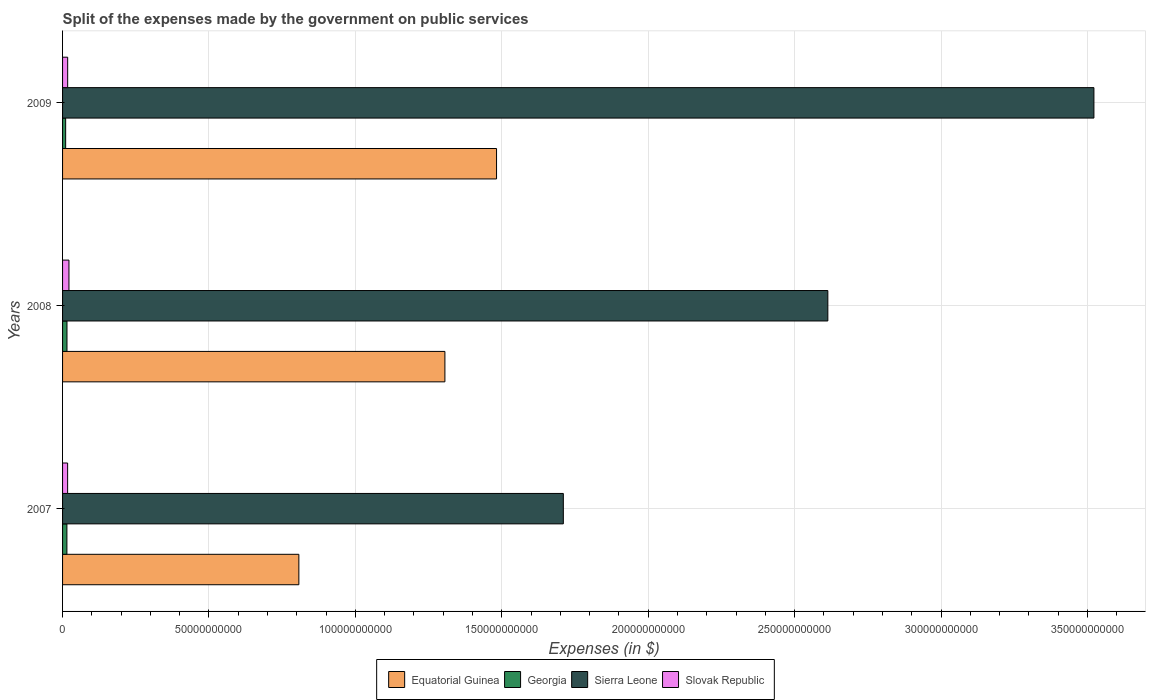How many different coloured bars are there?
Give a very brief answer. 4. Are the number of bars per tick equal to the number of legend labels?
Give a very brief answer. Yes. How many bars are there on the 3rd tick from the bottom?
Your answer should be very brief. 4. What is the expenses made by the government on public services in Equatorial Guinea in 2007?
Your response must be concise. 8.07e+1. Across all years, what is the maximum expenses made by the government on public services in Slovak Republic?
Provide a short and direct response. 2.18e+09. Across all years, what is the minimum expenses made by the government on public services in Slovak Republic?
Keep it short and to the point. 1.73e+09. What is the total expenses made by the government on public services in Equatorial Guinea in the graph?
Give a very brief answer. 3.59e+11. What is the difference between the expenses made by the government on public services in Sierra Leone in 2008 and that in 2009?
Provide a succinct answer. -9.09e+1. What is the difference between the expenses made by the government on public services in Equatorial Guinea in 2008 and the expenses made by the government on public services in Georgia in 2007?
Provide a succinct answer. 1.29e+11. What is the average expenses made by the government on public services in Georgia per year?
Provide a short and direct response. 1.35e+09. In the year 2007, what is the difference between the expenses made by the government on public services in Georgia and expenses made by the government on public services in Slovak Republic?
Keep it short and to the point. -2.45e+08. In how many years, is the expenses made by the government on public services in Sierra Leone greater than 90000000000 $?
Offer a terse response. 3. What is the ratio of the expenses made by the government on public services in Sierra Leone in 2007 to that in 2008?
Offer a very short reply. 0.65. Is the difference between the expenses made by the government on public services in Georgia in 2007 and 2008 greater than the difference between the expenses made by the government on public services in Slovak Republic in 2007 and 2008?
Give a very brief answer. Yes. What is the difference between the highest and the second highest expenses made by the government on public services in Equatorial Guinea?
Provide a short and direct response. 1.76e+1. What is the difference between the highest and the lowest expenses made by the government on public services in Georgia?
Your response must be concise. 4.54e+08. Is the sum of the expenses made by the government on public services in Georgia in 2007 and 2009 greater than the maximum expenses made by the government on public services in Sierra Leone across all years?
Ensure brevity in your answer.  No. Is it the case that in every year, the sum of the expenses made by the government on public services in Georgia and expenses made by the government on public services in Equatorial Guinea is greater than the sum of expenses made by the government on public services in Sierra Leone and expenses made by the government on public services in Slovak Republic?
Ensure brevity in your answer.  Yes. What does the 1st bar from the top in 2007 represents?
Give a very brief answer. Slovak Republic. What does the 3rd bar from the bottom in 2008 represents?
Your answer should be very brief. Sierra Leone. How many bars are there?
Your answer should be very brief. 12. What is the difference between two consecutive major ticks on the X-axis?
Offer a terse response. 5.00e+1. Are the values on the major ticks of X-axis written in scientific E-notation?
Offer a terse response. No. Does the graph contain grids?
Your answer should be very brief. Yes. Where does the legend appear in the graph?
Ensure brevity in your answer.  Bottom center. How many legend labels are there?
Make the answer very short. 4. What is the title of the graph?
Ensure brevity in your answer.  Split of the expenses made by the government on public services. Does "Vanuatu" appear as one of the legend labels in the graph?
Offer a terse response. No. What is the label or title of the X-axis?
Provide a succinct answer. Expenses (in $). What is the Expenses (in $) in Equatorial Guinea in 2007?
Offer a very short reply. 8.07e+1. What is the Expenses (in $) of Georgia in 2007?
Provide a short and direct response. 1.48e+09. What is the Expenses (in $) of Sierra Leone in 2007?
Keep it short and to the point. 1.71e+11. What is the Expenses (in $) of Slovak Republic in 2007?
Offer a terse response. 1.73e+09. What is the Expenses (in $) of Equatorial Guinea in 2008?
Ensure brevity in your answer.  1.31e+11. What is the Expenses (in $) of Georgia in 2008?
Your answer should be compact. 1.51e+09. What is the Expenses (in $) in Sierra Leone in 2008?
Make the answer very short. 2.61e+11. What is the Expenses (in $) of Slovak Republic in 2008?
Make the answer very short. 2.18e+09. What is the Expenses (in $) of Equatorial Guinea in 2009?
Your response must be concise. 1.48e+11. What is the Expenses (in $) of Georgia in 2009?
Ensure brevity in your answer.  1.06e+09. What is the Expenses (in $) in Sierra Leone in 2009?
Your answer should be very brief. 3.52e+11. What is the Expenses (in $) in Slovak Republic in 2009?
Offer a very short reply. 1.74e+09. Across all years, what is the maximum Expenses (in $) of Equatorial Guinea?
Ensure brevity in your answer.  1.48e+11. Across all years, what is the maximum Expenses (in $) of Georgia?
Offer a terse response. 1.51e+09. Across all years, what is the maximum Expenses (in $) of Sierra Leone?
Your response must be concise. 3.52e+11. Across all years, what is the maximum Expenses (in $) of Slovak Republic?
Provide a succinct answer. 2.18e+09. Across all years, what is the minimum Expenses (in $) in Equatorial Guinea?
Provide a succinct answer. 8.07e+1. Across all years, what is the minimum Expenses (in $) in Georgia?
Offer a very short reply. 1.06e+09. Across all years, what is the minimum Expenses (in $) in Sierra Leone?
Make the answer very short. 1.71e+11. Across all years, what is the minimum Expenses (in $) of Slovak Republic?
Your response must be concise. 1.73e+09. What is the total Expenses (in $) in Equatorial Guinea in the graph?
Keep it short and to the point. 3.59e+11. What is the total Expenses (in $) in Georgia in the graph?
Offer a terse response. 4.05e+09. What is the total Expenses (in $) of Sierra Leone in the graph?
Ensure brevity in your answer.  7.85e+11. What is the total Expenses (in $) of Slovak Republic in the graph?
Your response must be concise. 5.65e+09. What is the difference between the Expenses (in $) in Equatorial Guinea in 2007 and that in 2008?
Provide a short and direct response. -4.99e+1. What is the difference between the Expenses (in $) of Georgia in 2007 and that in 2008?
Offer a very short reply. -2.49e+07. What is the difference between the Expenses (in $) in Sierra Leone in 2007 and that in 2008?
Your answer should be very brief. -9.03e+1. What is the difference between the Expenses (in $) in Slovak Republic in 2007 and that in 2008?
Offer a terse response. -4.53e+08. What is the difference between the Expenses (in $) in Equatorial Guinea in 2007 and that in 2009?
Your answer should be compact. -6.75e+1. What is the difference between the Expenses (in $) of Georgia in 2007 and that in 2009?
Ensure brevity in your answer.  4.29e+08. What is the difference between the Expenses (in $) in Sierra Leone in 2007 and that in 2009?
Your response must be concise. -1.81e+11. What is the difference between the Expenses (in $) in Slovak Republic in 2007 and that in 2009?
Provide a succinct answer. -1.42e+07. What is the difference between the Expenses (in $) in Equatorial Guinea in 2008 and that in 2009?
Provide a short and direct response. -1.76e+1. What is the difference between the Expenses (in $) in Georgia in 2008 and that in 2009?
Give a very brief answer. 4.54e+08. What is the difference between the Expenses (in $) of Sierra Leone in 2008 and that in 2009?
Offer a terse response. -9.09e+1. What is the difference between the Expenses (in $) of Slovak Republic in 2008 and that in 2009?
Your answer should be compact. 4.39e+08. What is the difference between the Expenses (in $) of Equatorial Guinea in 2007 and the Expenses (in $) of Georgia in 2008?
Ensure brevity in your answer.  7.92e+1. What is the difference between the Expenses (in $) of Equatorial Guinea in 2007 and the Expenses (in $) of Sierra Leone in 2008?
Provide a succinct answer. -1.81e+11. What is the difference between the Expenses (in $) in Equatorial Guinea in 2007 and the Expenses (in $) in Slovak Republic in 2008?
Give a very brief answer. 7.85e+1. What is the difference between the Expenses (in $) in Georgia in 2007 and the Expenses (in $) in Sierra Leone in 2008?
Provide a short and direct response. -2.60e+11. What is the difference between the Expenses (in $) of Georgia in 2007 and the Expenses (in $) of Slovak Republic in 2008?
Provide a succinct answer. -6.98e+08. What is the difference between the Expenses (in $) of Sierra Leone in 2007 and the Expenses (in $) of Slovak Republic in 2008?
Ensure brevity in your answer.  1.69e+11. What is the difference between the Expenses (in $) of Equatorial Guinea in 2007 and the Expenses (in $) of Georgia in 2009?
Your answer should be very brief. 7.96e+1. What is the difference between the Expenses (in $) of Equatorial Guinea in 2007 and the Expenses (in $) of Sierra Leone in 2009?
Make the answer very short. -2.71e+11. What is the difference between the Expenses (in $) in Equatorial Guinea in 2007 and the Expenses (in $) in Slovak Republic in 2009?
Offer a terse response. 7.89e+1. What is the difference between the Expenses (in $) in Georgia in 2007 and the Expenses (in $) in Sierra Leone in 2009?
Offer a very short reply. -3.51e+11. What is the difference between the Expenses (in $) of Georgia in 2007 and the Expenses (in $) of Slovak Republic in 2009?
Provide a short and direct response. -2.60e+08. What is the difference between the Expenses (in $) of Sierra Leone in 2007 and the Expenses (in $) of Slovak Republic in 2009?
Your response must be concise. 1.69e+11. What is the difference between the Expenses (in $) in Equatorial Guinea in 2008 and the Expenses (in $) in Georgia in 2009?
Keep it short and to the point. 1.30e+11. What is the difference between the Expenses (in $) in Equatorial Guinea in 2008 and the Expenses (in $) in Sierra Leone in 2009?
Provide a short and direct response. -2.22e+11. What is the difference between the Expenses (in $) of Equatorial Guinea in 2008 and the Expenses (in $) of Slovak Republic in 2009?
Offer a terse response. 1.29e+11. What is the difference between the Expenses (in $) in Georgia in 2008 and the Expenses (in $) in Sierra Leone in 2009?
Your response must be concise. -3.51e+11. What is the difference between the Expenses (in $) in Georgia in 2008 and the Expenses (in $) in Slovak Republic in 2009?
Give a very brief answer. -2.35e+08. What is the difference between the Expenses (in $) of Sierra Leone in 2008 and the Expenses (in $) of Slovak Republic in 2009?
Make the answer very short. 2.60e+11. What is the average Expenses (in $) in Equatorial Guinea per year?
Make the answer very short. 1.20e+11. What is the average Expenses (in $) in Georgia per year?
Offer a terse response. 1.35e+09. What is the average Expenses (in $) of Sierra Leone per year?
Provide a succinct answer. 2.62e+11. What is the average Expenses (in $) of Slovak Republic per year?
Provide a succinct answer. 1.88e+09. In the year 2007, what is the difference between the Expenses (in $) in Equatorial Guinea and Expenses (in $) in Georgia?
Provide a succinct answer. 7.92e+1. In the year 2007, what is the difference between the Expenses (in $) of Equatorial Guinea and Expenses (in $) of Sierra Leone?
Your response must be concise. -9.03e+1. In the year 2007, what is the difference between the Expenses (in $) in Equatorial Guinea and Expenses (in $) in Slovak Republic?
Ensure brevity in your answer.  7.90e+1. In the year 2007, what is the difference between the Expenses (in $) of Georgia and Expenses (in $) of Sierra Leone?
Your response must be concise. -1.70e+11. In the year 2007, what is the difference between the Expenses (in $) in Georgia and Expenses (in $) in Slovak Republic?
Give a very brief answer. -2.45e+08. In the year 2007, what is the difference between the Expenses (in $) in Sierra Leone and Expenses (in $) in Slovak Republic?
Offer a terse response. 1.69e+11. In the year 2008, what is the difference between the Expenses (in $) of Equatorial Guinea and Expenses (in $) of Georgia?
Give a very brief answer. 1.29e+11. In the year 2008, what is the difference between the Expenses (in $) of Equatorial Guinea and Expenses (in $) of Sierra Leone?
Offer a very short reply. -1.31e+11. In the year 2008, what is the difference between the Expenses (in $) in Equatorial Guinea and Expenses (in $) in Slovak Republic?
Provide a succinct answer. 1.28e+11. In the year 2008, what is the difference between the Expenses (in $) in Georgia and Expenses (in $) in Sierra Leone?
Offer a terse response. -2.60e+11. In the year 2008, what is the difference between the Expenses (in $) in Georgia and Expenses (in $) in Slovak Republic?
Make the answer very short. -6.74e+08. In the year 2008, what is the difference between the Expenses (in $) in Sierra Leone and Expenses (in $) in Slovak Republic?
Make the answer very short. 2.59e+11. In the year 2009, what is the difference between the Expenses (in $) of Equatorial Guinea and Expenses (in $) of Georgia?
Provide a short and direct response. 1.47e+11. In the year 2009, what is the difference between the Expenses (in $) of Equatorial Guinea and Expenses (in $) of Sierra Leone?
Your answer should be compact. -2.04e+11. In the year 2009, what is the difference between the Expenses (in $) in Equatorial Guinea and Expenses (in $) in Slovak Republic?
Your response must be concise. 1.46e+11. In the year 2009, what is the difference between the Expenses (in $) of Georgia and Expenses (in $) of Sierra Leone?
Ensure brevity in your answer.  -3.51e+11. In the year 2009, what is the difference between the Expenses (in $) of Georgia and Expenses (in $) of Slovak Republic?
Keep it short and to the point. -6.88e+08. In the year 2009, what is the difference between the Expenses (in $) of Sierra Leone and Expenses (in $) of Slovak Republic?
Your answer should be compact. 3.50e+11. What is the ratio of the Expenses (in $) in Equatorial Guinea in 2007 to that in 2008?
Your answer should be very brief. 0.62. What is the ratio of the Expenses (in $) in Georgia in 2007 to that in 2008?
Keep it short and to the point. 0.98. What is the ratio of the Expenses (in $) in Sierra Leone in 2007 to that in 2008?
Your response must be concise. 0.65. What is the ratio of the Expenses (in $) of Slovak Republic in 2007 to that in 2008?
Make the answer very short. 0.79. What is the ratio of the Expenses (in $) in Equatorial Guinea in 2007 to that in 2009?
Make the answer very short. 0.54. What is the ratio of the Expenses (in $) of Georgia in 2007 to that in 2009?
Ensure brevity in your answer.  1.41. What is the ratio of the Expenses (in $) of Sierra Leone in 2007 to that in 2009?
Keep it short and to the point. 0.49. What is the ratio of the Expenses (in $) of Equatorial Guinea in 2008 to that in 2009?
Your answer should be compact. 0.88. What is the ratio of the Expenses (in $) of Georgia in 2008 to that in 2009?
Ensure brevity in your answer.  1.43. What is the ratio of the Expenses (in $) in Sierra Leone in 2008 to that in 2009?
Give a very brief answer. 0.74. What is the ratio of the Expenses (in $) in Slovak Republic in 2008 to that in 2009?
Your answer should be very brief. 1.25. What is the difference between the highest and the second highest Expenses (in $) in Equatorial Guinea?
Give a very brief answer. 1.76e+1. What is the difference between the highest and the second highest Expenses (in $) in Georgia?
Provide a succinct answer. 2.49e+07. What is the difference between the highest and the second highest Expenses (in $) in Sierra Leone?
Keep it short and to the point. 9.09e+1. What is the difference between the highest and the second highest Expenses (in $) of Slovak Republic?
Provide a succinct answer. 4.39e+08. What is the difference between the highest and the lowest Expenses (in $) of Equatorial Guinea?
Provide a short and direct response. 6.75e+1. What is the difference between the highest and the lowest Expenses (in $) in Georgia?
Provide a short and direct response. 4.54e+08. What is the difference between the highest and the lowest Expenses (in $) in Sierra Leone?
Provide a succinct answer. 1.81e+11. What is the difference between the highest and the lowest Expenses (in $) of Slovak Republic?
Your response must be concise. 4.53e+08. 